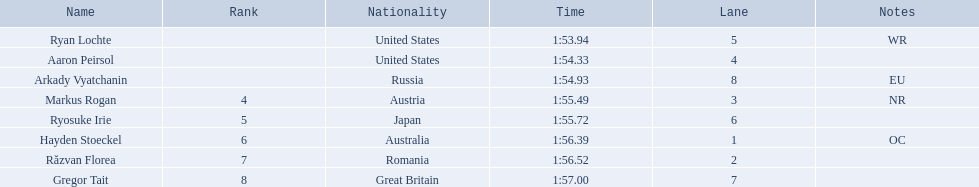What is the name of the contestant in lane 6? Ryosuke Irie. How long did it take that player to complete the race? 1:55.72. 